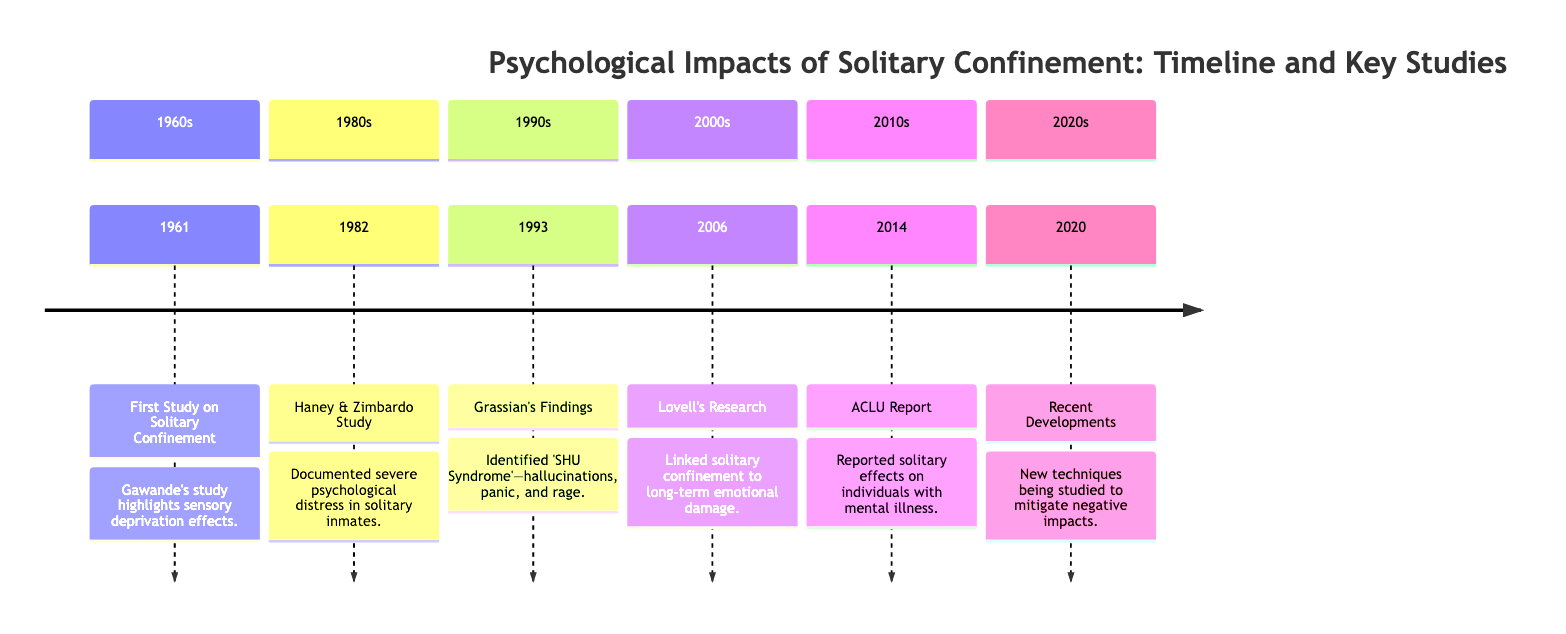What was the first study on solitary confinement? The diagram indicates that the first study was conducted in 1961 by Gawande, which highlights the effects of sensory deprivation.
Answer: Gawande's study What syndrome was identified in 1993? The diagram shows that Grassian's findings in 1993 identified 'SHU Syndrome', which includes hallucinations, panic, and rage.
Answer: SHU Syndrome Which study linked solitary confinement to long-term emotional damage? According to the diagram, Lovell's research in 2006 made this link between solitary confinement and long-term emotional damage.
Answer: Lovell's Research What year did the ACLU report report on the effects of solitary confinement? The timeline specifies that the ACLU report came out in 2014, focusing on the effects of solitary confinement on individuals with mental illness.
Answer: 2014 How many key studies are listed in the 1980s? The diagram lists one key study in the 1980s, specifically the Haney & Zimbardo study in 1982, which documented severe psychological distress.
Answer: 1 What decade did recent developments occur? The timeline indicates that recent developments regarding new techniques being studied to mitigate negative impacts occurred in the 2020s.
Answer: 2020s What was documented in the 1982 study? The diagram indicates that the 1982 Haney & Zimbardo study documented severe psychological distress in solitary inmates.
Answer: Severe psychological distress Which researcher conducted a study on solitary confinement effects in the 2006? The diagram indicates that Lovell conducted research in 2006 that linked solitary confinement to long-term emotional damage.
Answer: Lovell What type of effects did the 2014 ACLU report focus on? The ACLU report in 2014 focused on the effects of solitary confinement on individuals with mental illness, as shown in the diagram.
Answer: Mental illness effects 